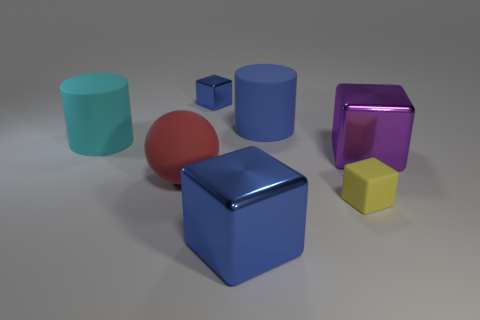Add 1 rubber cylinders. How many objects exist? 8 Subtract all cylinders. How many objects are left? 5 Subtract 0 yellow cylinders. How many objects are left? 7 Subtract all small brown shiny spheres. Subtract all tiny cubes. How many objects are left? 5 Add 6 large rubber cylinders. How many large rubber cylinders are left? 8 Add 1 cyan matte balls. How many cyan matte balls exist? 1 